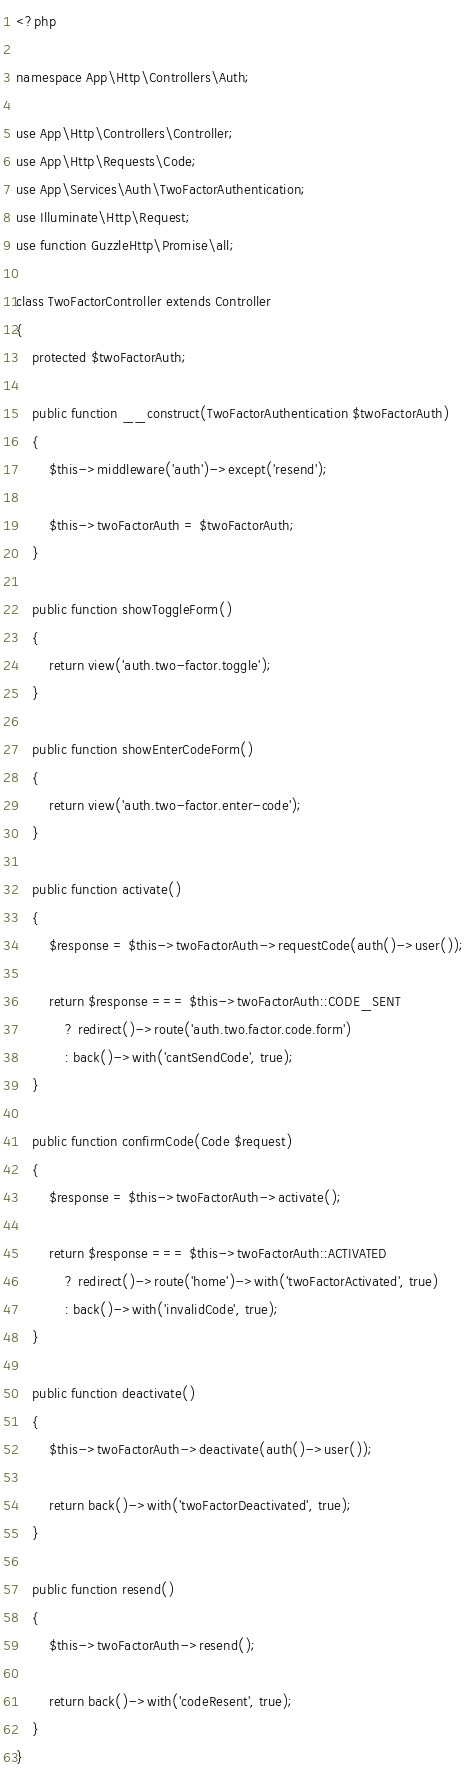Convert code to text. <code><loc_0><loc_0><loc_500><loc_500><_PHP_><?php

namespace App\Http\Controllers\Auth;

use App\Http\Controllers\Controller;
use App\Http\Requests\Code;
use App\Services\Auth\TwoFactorAuthentication;
use Illuminate\Http\Request;
use function GuzzleHttp\Promise\all;

class TwoFactorController extends Controller
{
    protected $twoFactorAuth;

    public function __construct(TwoFactorAuthentication $twoFactorAuth)
    {
        $this->middleware('auth')->except('resend');

        $this->twoFactorAuth = $twoFactorAuth;
    }

    public function showToggleForm()
    {
        return view('auth.two-factor.toggle');
    }

    public function showEnterCodeForm()
    {
        return view('auth.two-factor.enter-code');
    }

    public function activate()
    {
        $response = $this->twoFactorAuth->requestCode(auth()->user());

        return $response === $this->twoFactorAuth::CODE_SENT
            ? redirect()->route('auth.two.factor.code.form')
            : back()->with('cantSendCode', true);
    }

    public function confirmCode(Code $request)
    {
        $response = $this->twoFactorAuth->activate();

        return $response === $this->twoFactorAuth::ACTIVATED
            ? redirect()->route('home')->with('twoFactorActivated', true)
            : back()->with('invalidCode', true);
    }

    public function deactivate()
    {
        $this->twoFactorAuth->deactivate(auth()->user());

        return back()->with('twoFactorDeactivated', true);
    }

    public function resend()
    {
        $this->twoFactorAuth->resend();

        return back()->with('codeResent', true);
    }
}
</code> 